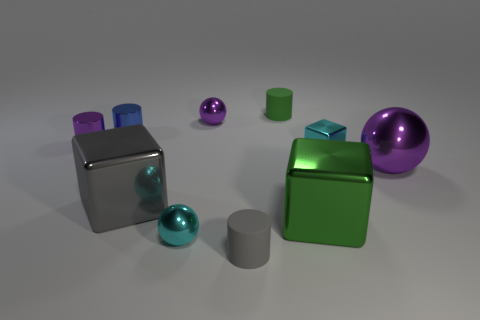Subtract all tiny purple metallic cylinders. How many cylinders are left? 3 Subtract all gray cylinders. How many cylinders are left? 3 Subtract all cyan cylinders. Subtract all gray cubes. How many cylinders are left? 4 Subtract all balls. How many objects are left? 7 Add 3 big purple spheres. How many big purple spheres are left? 4 Add 9 blue metal things. How many blue metal things exist? 10 Subtract 0 blue spheres. How many objects are left? 10 Subtract all large metal spheres. Subtract all tiny blue metallic things. How many objects are left? 8 